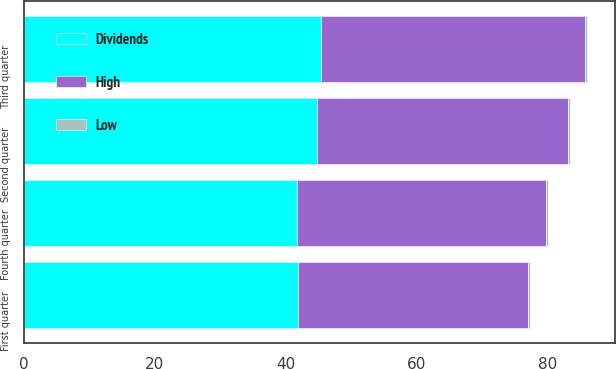Convert chart. <chart><loc_0><loc_0><loc_500><loc_500><stacked_bar_chart><ecel><fcel>First quarter<fcel>Second quarter<fcel>Third quarter<fcel>Fourth quarter<nl><fcel>Dividends<fcel>41.85<fcel>44.78<fcel>45.42<fcel>41.8<nl><fcel>High<fcel>35.19<fcel>38.43<fcel>40.34<fcel>38<nl><fcel>Low<fcel>0.34<fcel>0.34<fcel>0.34<fcel>0.34<nl></chart> 